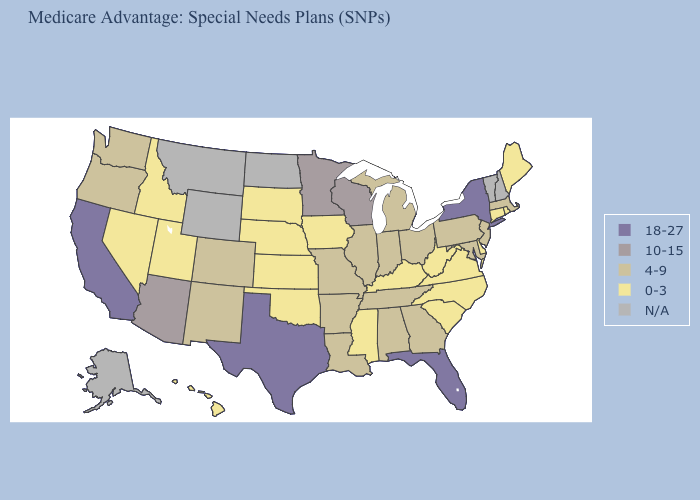What is the value of Texas?
Quick response, please. 18-27. Among the states that border Vermont , does Massachusetts have the lowest value?
Concise answer only. Yes. Name the states that have a value in the range N/A?
Write a very short answer. Alaska, Montana, North Dakota, New Hampshire, Vermont, Wyoming. What is the highest value in the USA?
Give a very brief answer. 18-27. Does California have the highest value in the USA?
Give a very brief answer. Yes. Does California have the highest value in the USA?
Keep it brief. Yes. What is the value of Minnesota?
Write a very short answer. 10-15. Name the states that have a value in the range 10-15?
Be succinct. Arizona, Minnesota, Wisconsin. Among the states that border Illinois , which have the lowest value?
Give a very brief answer. Iowa, Kentucky. Name the states that have a value in the range 18-27?
Be succinct. California, Florida, New York, Texas. What is the lowest value in states that border Washington?
Be succinct. 0-3. What is the value of Louisiana?
Be succinct. 4-9. Is the legend a continuous bar?
Short answer required. No. Name the states that have a value in the range 18-27?
Quick response, please. California, Florida, New York, Texas. Name the states that have a value in the range N/A?
Quick response, please. Alaska, Montana, North Dakota, New Hampshire, Vermont, Wyoming. 